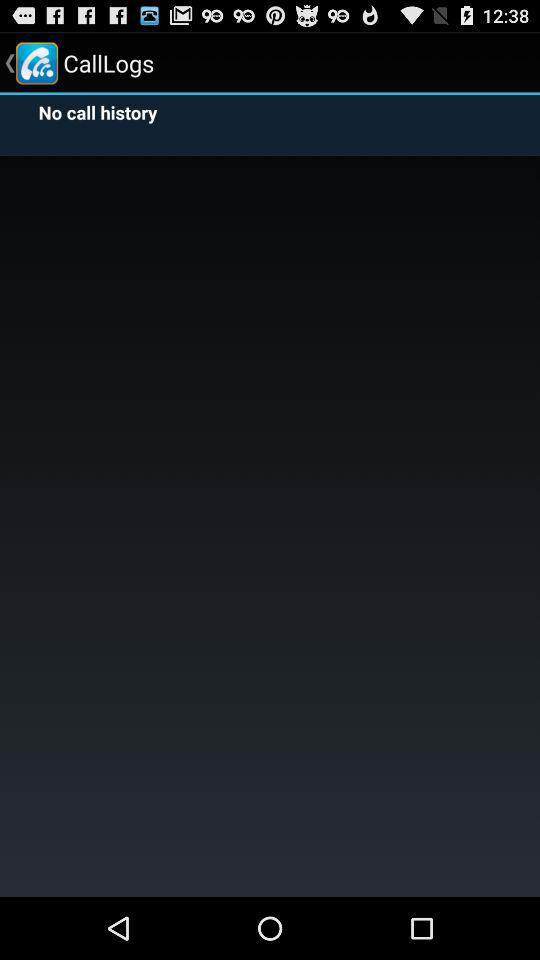Is there any call history? There is no call history. 